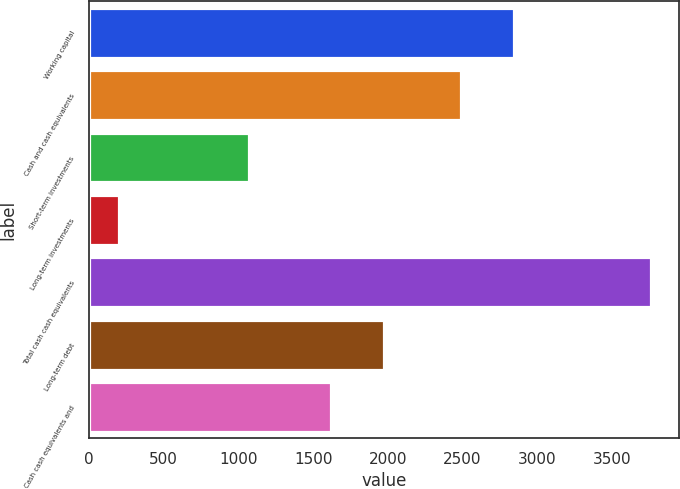Convert chart. <chart><loc_0><loc_0><loc_500><loc_500><bar_chart><fcel>Working capital<fcel>Cash and cash equivalents<fcel>Short-term investments<fcel>Long-term investments<fcel>Total cash cash equivalents<fcel>Long-term debt<fcel>Cash cash equivalents and<nl><fcel>2844.91<fcel>2489<fcel>1070.1<fcel>199<fcel>3758.1<fcel>1975.01<fcel>1619.1<nl></chart> 